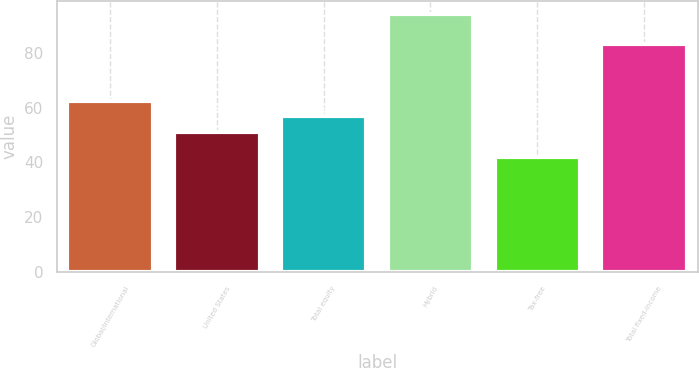Convert chart to OTSL. <chart><loc_0><loc_0><loc_500><loc_500><bar_chart><fcel>Global/international<fcel>United States<fcel>Total equity<fcel>Hybrid<fcel>Tax-free<fcel>Total fixed-income<nl><fcel>62.2<fcel>51<fcel>57<fcel>94<fcel>42<fcel>83<nl></chart> 